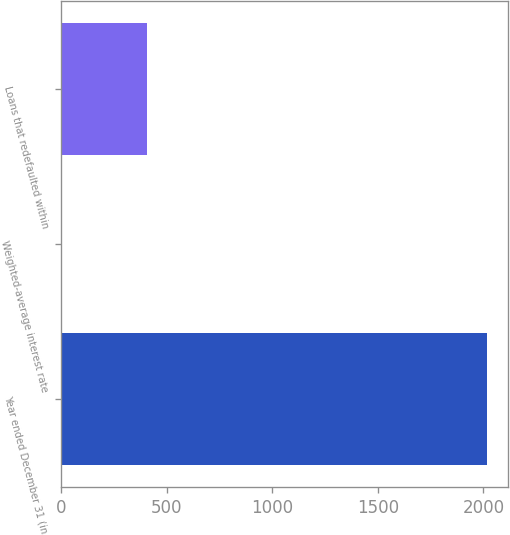Convert chart. <chart><loc_0><loc_0><loc_500><loc_500><bar_chart><fcel>Year ended December 31 (in<fcel>Weighted-average interest rate<fcel>Loans that redefaulted within<nl><fcel>2017<fcel>4.88<fcel>407.3<nl></chart> 